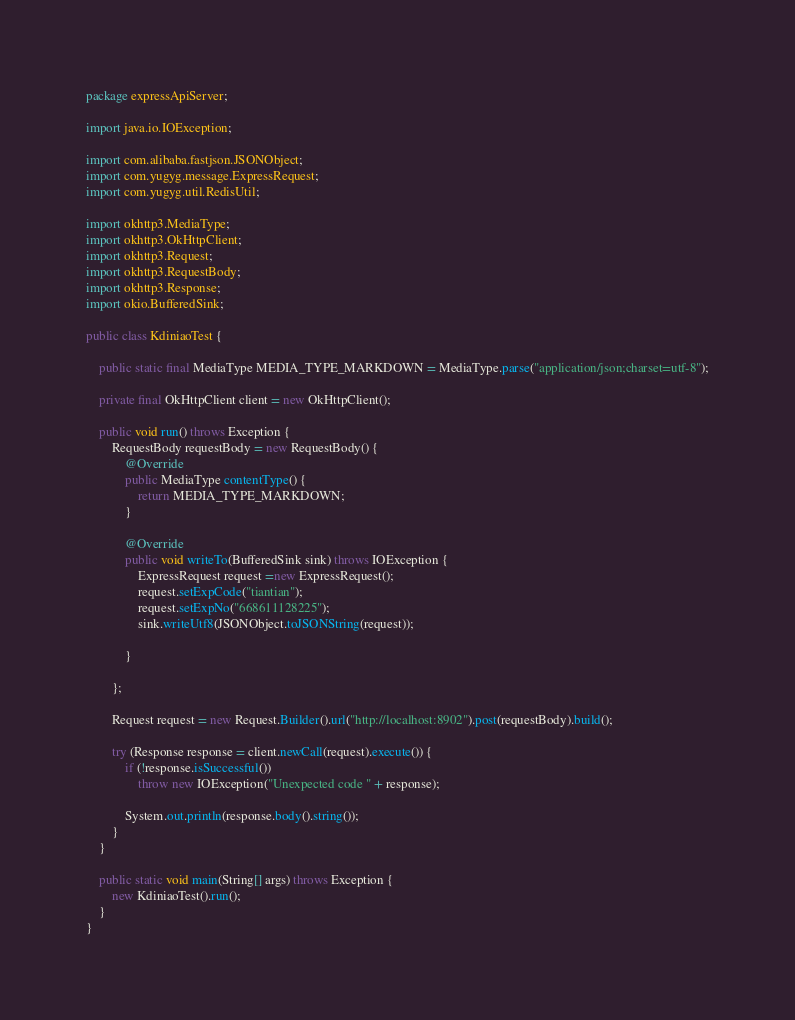Convert code to text. <code><loc_0><loc_0><loc_500><loc_500><_Java_>package expressApiServer;

import java.io.IOException;

import com.alibaba.fastjson.JSONObject;
import com.yugyg.message.ExpressRequest;
import com.yugyg.util.RedisUtil;

import okhttp3.MediaType;
import okhttp3.OkHttpClient;
import okhttp3.Request;
import okhttp3.RequestBody;
import okhttp3.Response;
import okio.BufferedSink;

public class KdiniaoTest {

	public static final MediaType MEDIA_TYPE_MARKDOWN = MediaType.parse("application/json;charset=utf-8");

	private final OkHttpClient client = new OkHttpClient();

	public void run() throws Exception {
		RequestBody requestBody = new RequestBody() {
			@Override
			public MediaType contentType() {
				return MEDIA_TYPE_MARKDOWN;
			}

			@Override
			public void writeTo(BufferedSink sink) throws IOException {
				ExpressRequest request =new ExpressRequest();
				request.setExpCode("tiantian");
				request.setExpNo("668611128225");
				sink.writeUtf8(JSONObject.toJSONString(request));
				
			}

		};

		Request request = new Request.Builder().url("http://localhost:8902").post(requestBody).build();

		try (Response response = client.newCall(request).execute()) {
			if (!response.isSuccessful())
				throw new IOException("Unexpected code " + response);

			System.out.println(response.body().string());
		}
	}
	
	public static void main(String[] args) throws Exception {
		new KdiniaoTest().run();
	}
}
</code> 